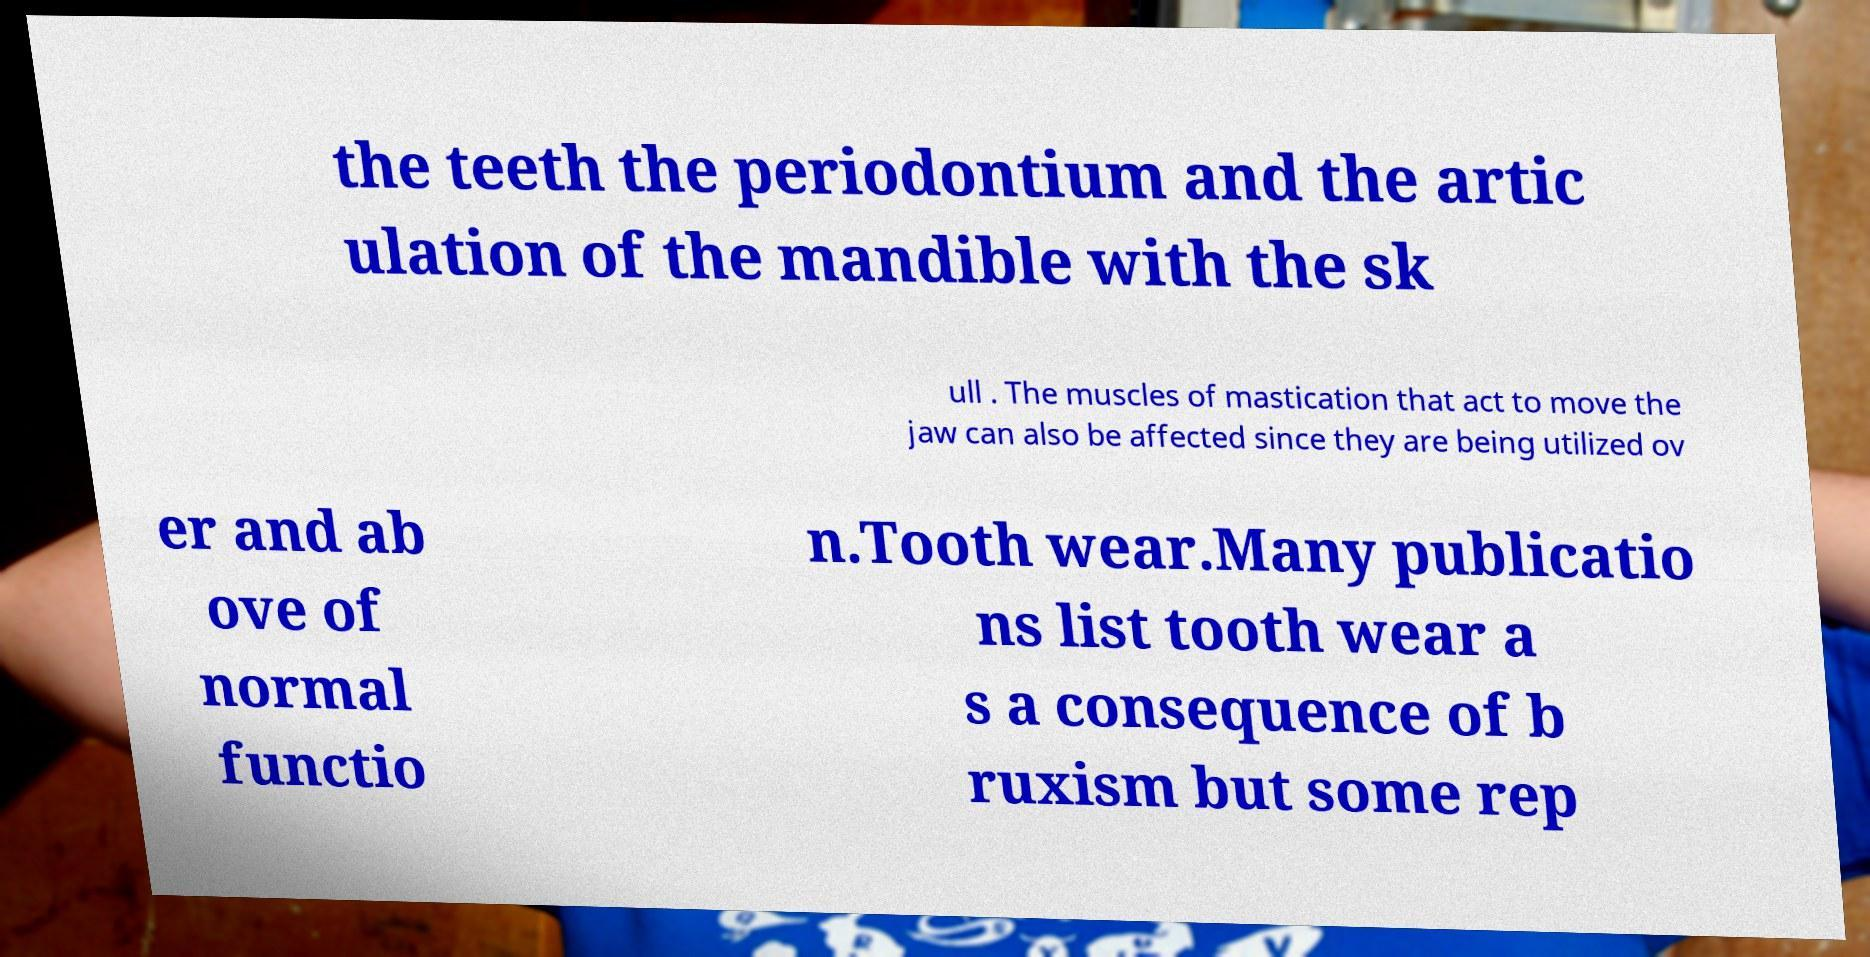Can you accurately transcribe the text from the provided image for me? the teeth the periodontium and the artic ulation of the mandible with the sk ull . The muscles of mastication that act to move the jaw can also be affected since they are being utilized ov er and ab ove of normal functio n.Tooth wear.Many publicatio ns list tooth wear a s a consequence of b ruxism but some rep 